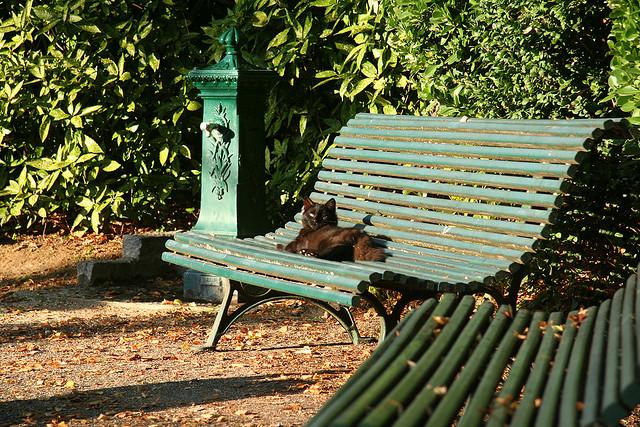Is this   photo indoors?
Answer briefly. No. Will these weeds overrun this bench?
Answer briefly. No. What is the cat laying on?
Be succinct. Bench. Is the cat awake?
Be succinct. Yes. 